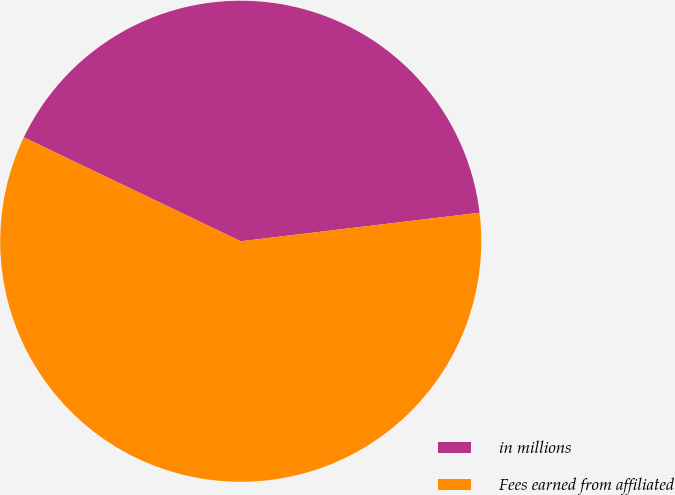<chart> <loc_0><loc_0><loc_500><loc_500><pie_chart><fcel>in millions<fcel>Fees earned from affiliated<nl><fcel>41.0%<fcel>59.0%<nl></chart> 